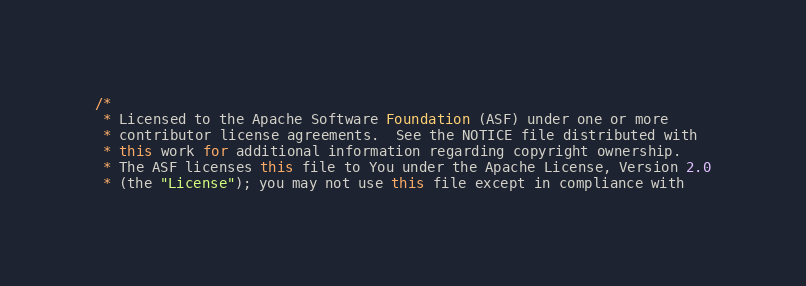<code> <loc_0><loc_0><loc_500><loc_500><_Java_>/*
 * Licensed to the Apache Software Foundation (ASF) under one or more
 * contributor license agreements.  See the NOTICE file distributed with
 * this work for additional information regarding copyright ownership.
 * The ASF licenses this file to You under the Apache License, Version 2.0
 * (the "License"); you may not use this file except in compliance with</code> 